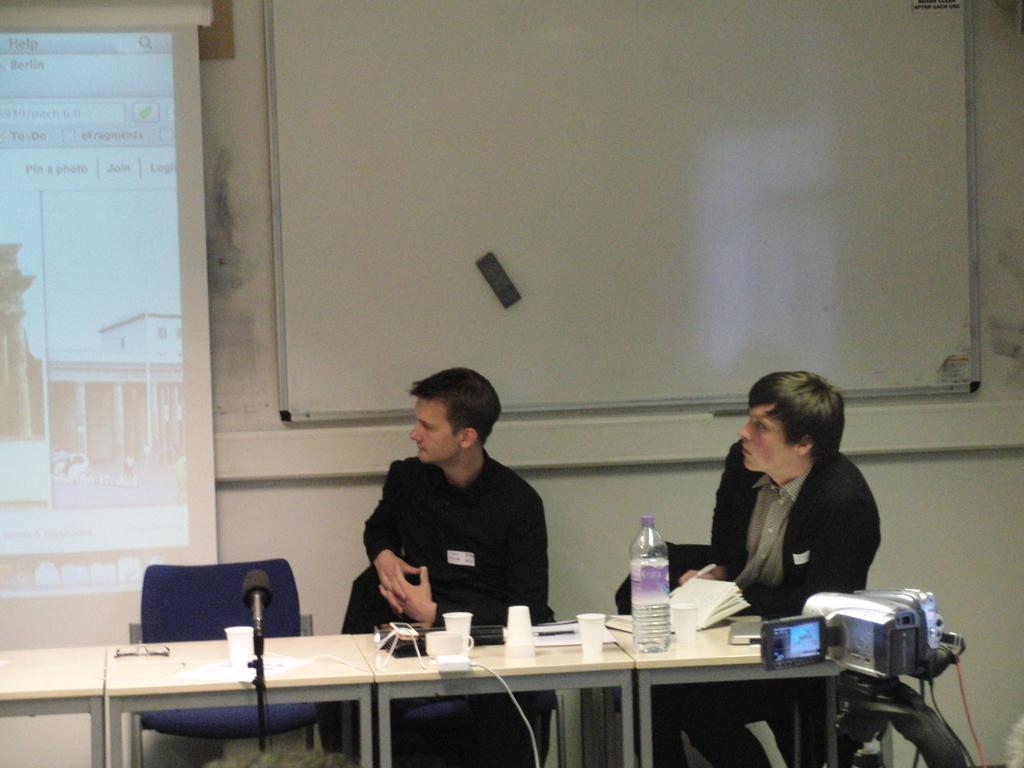Describe this image in one or two sentences. There are two men sitting on the chairs at the table. On the table we can see water bottle,books,microphone,cable,cups,laptop,mobile and some other objects. On the right we can see a camera on a stand. In the background there is a chair at the table,screen and a board on the wall. 